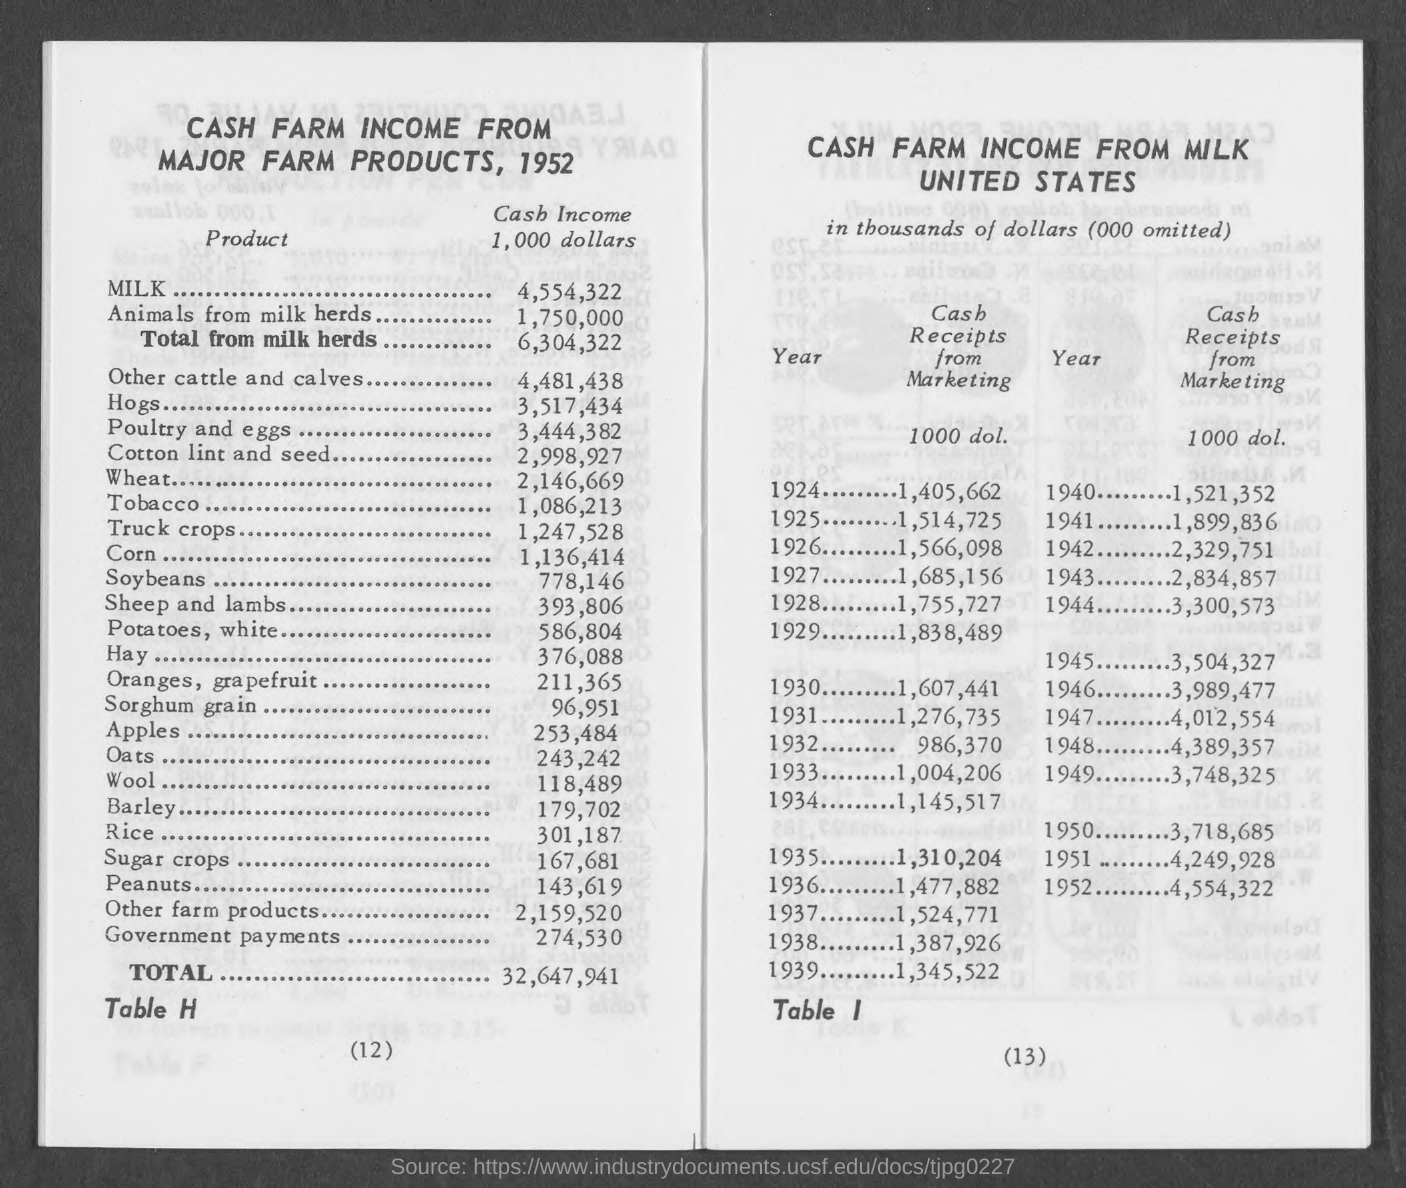What is the amount of cash income for milk mentioned in the given page ?
Give a very brief answer. 4,554,322. What is the amount of cash income for animals from milk herds mentioned in the given page ?
Keep it short and to the point. 1,750,000. What is the amount of cash income of total from milk herds mentioned in the given page ?
Offer a terse response. 6,304,322. What is the amount of cash income for hogs mentioned in the given page ?
Your answer should be very brief. 3,517,434. What is the amount of cash income of tobacco mentioned in the given page ?
Provide a short and direct response. 1,086,213. What is the amount of cash income of apples mentioned in the given page ?
Provide a short and direct response. 253,484. What is the amount of cash income of wool ?
Ensure brevity in your answer.  118,489. What is the amount of total cash income mentioned in the given page ?
Offer a terse response. 32,647,941. What is the amount of cash income of corn ?
Your response must be concise. 1,136,414. What is the amount of cash income of hay ?
Offer a terse response. 376,088. 